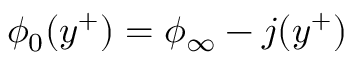<formula> <loc_0><loc_0><loc_500><loc_500>\phi _ { 0 } ( y ^ { + } ) = \phi _ { \infty } - j ( y ^ { + } )</formula> 